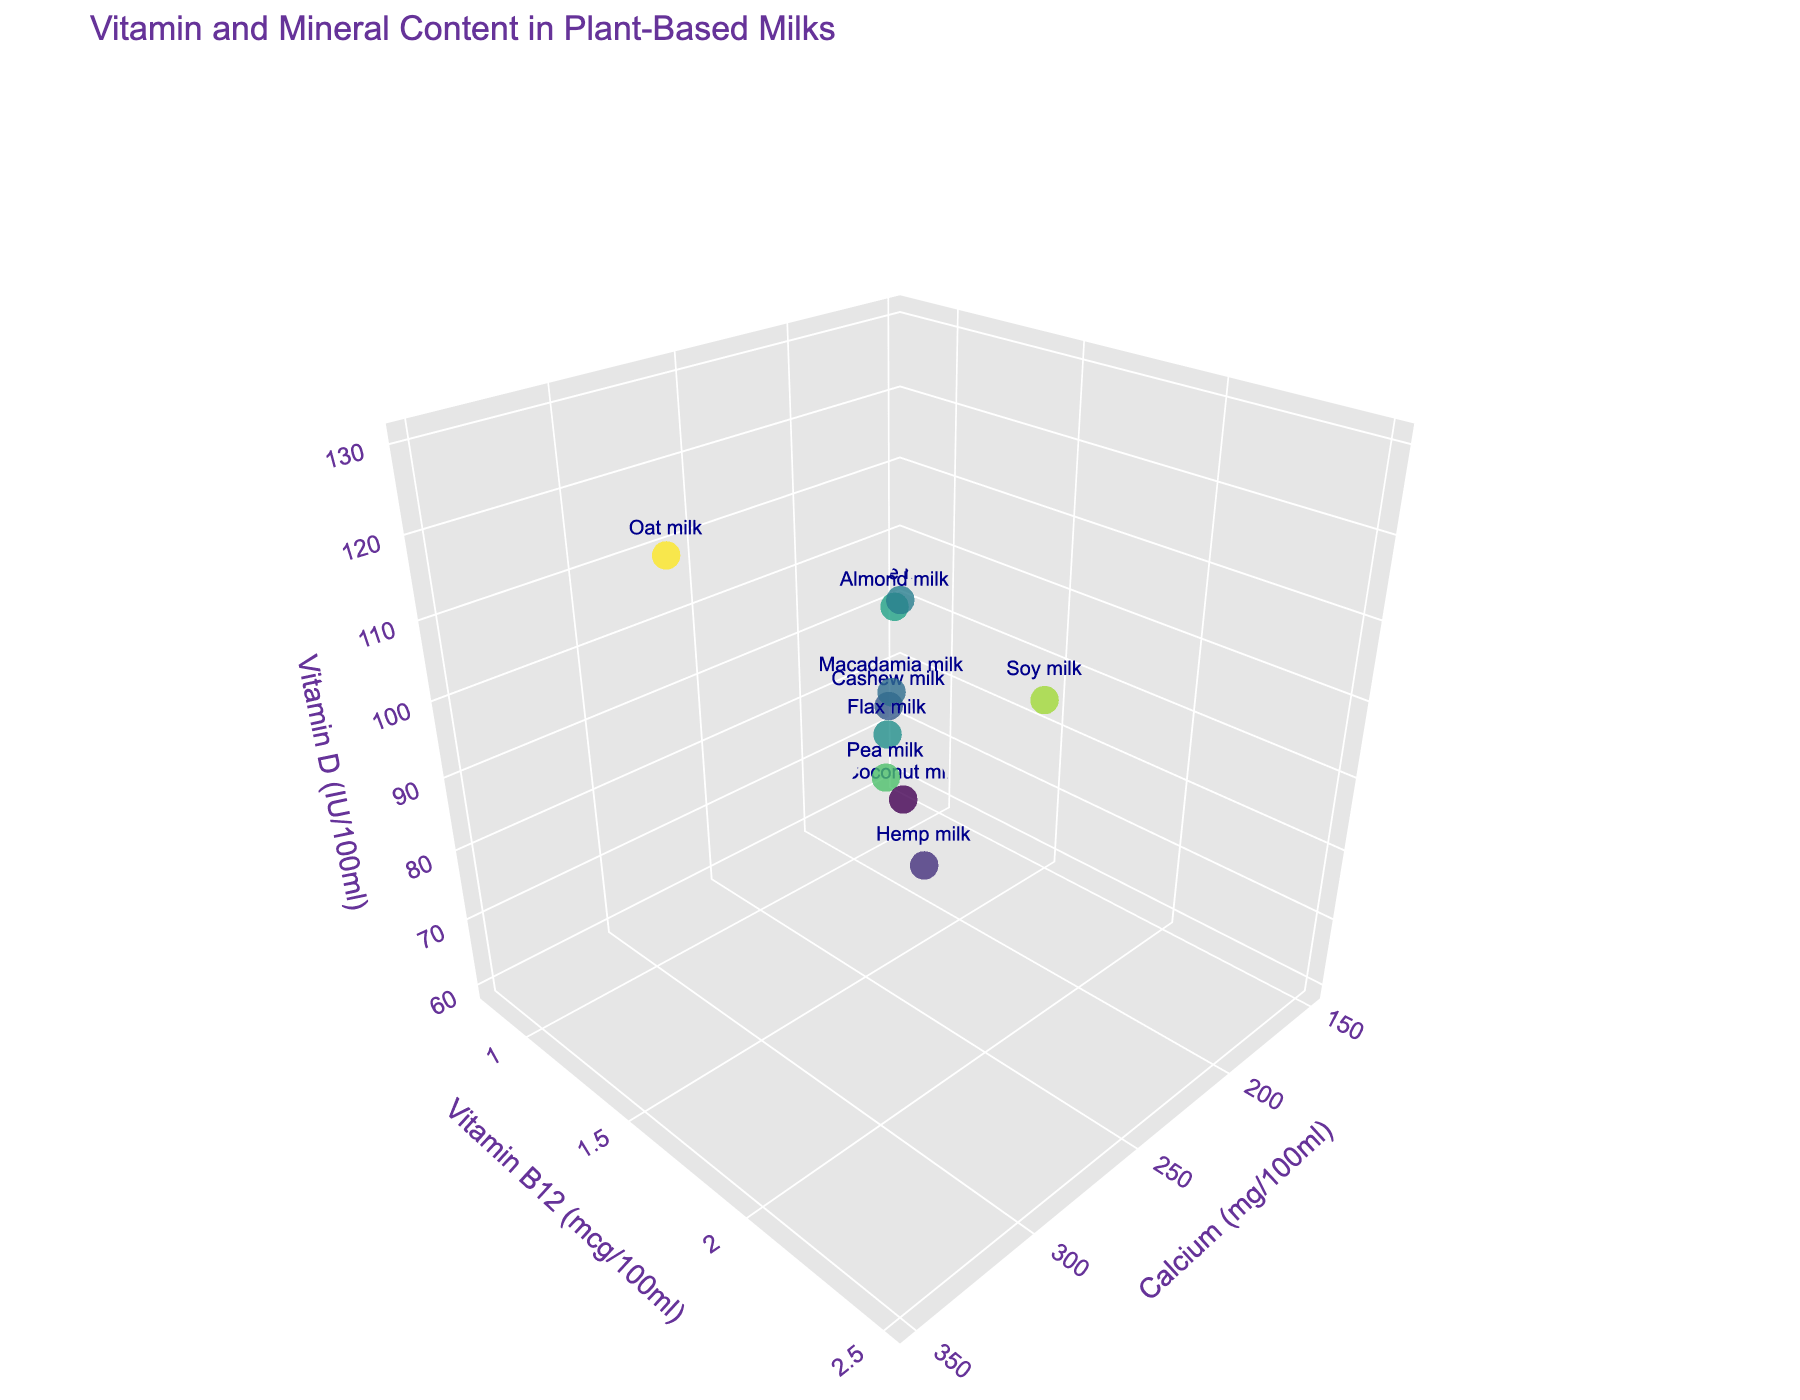What is the title of the plot? The title is usually located at the top of the plot and gives a summary of what the plot is about. Here, we can see the title "Vitamin and Mineral Content in Plant-Based Milks" at the top.
Answer: Vitamin and Mineral Content in Plant-Based Milks Which plant milk has the highest level of Calcium (mg/100ml)? To find the plant milk with the highest Calcium content, look at the x-axis values and identify the highest one. Oat milk is located at the furthest right, indicating the highest Calcium content of 350 mg/100ml.
Answer: Oat milk How many different plant milks are represented in the plot? Count all the unique points in the 3D scatter plot. There are ten different types, each corresponding to a different plant milk.
Answer: 10 Which plant milk has the lowest Vitamin D (IU/100ml) level? To identify the milk with the lowest Vitamin D content, look at the z-axis and find the lowest point. Coconut milk is the lowest with 60 IU/100ml.
Answer: Coconut milk How does Pea milk compare to Soy milk in terms of Vitamin B12 (mcg/100ml)? Compare the y-axis position of Pea milk and Soy milk. Pea milk has a Vitamin B12 level of 2.2 mcg/100ml while Soy milk has 2.5 mcg/100ml. Soy milk has a higher Vitamin B12 content.
Answer: Soy milk has higher Vitamin B12 content What is the total amount of Vitamin D (IU/100ml) in Almond milk and Cashew milk combined? Add the z-axis values of both Almond milk (100 IU/100ml) and Cashew milk (80 IU/100ml). 100 + 80 = 180 IU/100ml.
Answer: 180 IU/100ml Which plant milk appears to have the balance of mid-range values for all three nutrients? Find a point that is somewhat centered in the plot for all axes. Flax milk, with 250 mg/100ml Calcium, 1.6 mcg/100ml Vitamin B12, and 95 IU/100ml Vitamin D, seems to have mid-range values.
Answer: Flax milk Between Soy milk and Rice milk, which one has the higher amount of Calcium (mg/100ml)? Compare their positions on the x-axis. Soy milk has 300 mg/100ml while Rice milk has 150 mg/100ml. Soy milk has a higher Calcium content.
Answer: Soy milk What is the relationship between Vitamin B12 and Vitamin D levels in Oat milk and Pea milk? Look at the y-axis (Vitamin B12) and z-axis (Vitamin D) values for both milk types. Oat milk has 1.8 mcg/100ml Vitamin B12 and 130 IU/100ml Vitamin D, while Pea milk has 2.2 mcg/100ml Vitamin B12 and 110 IU/100ml Vitamin D. Oat milk has higher Vitamin D but lower Vitamin B12 compared to Pea milk.
Answer: Oat milk has higher Vitamin D but lower Vitamin B12 Which plant milks have a higher Vitamin D (IU/100ml) content than Hemp milk but lower than Soy milk? Look at the z-axis values of Hemp milk (70 IU/100ml) and Soy milk (120 IU/100ml), then find milk types that have Vitamin D levels within that range. Almond, Pea, and Oat milks have Vitamin D levels of 100, 110, and 130 IU/100ml respectively. Oat milk exceeds Soy milk.
Answer: Almond milk and Pea milk 